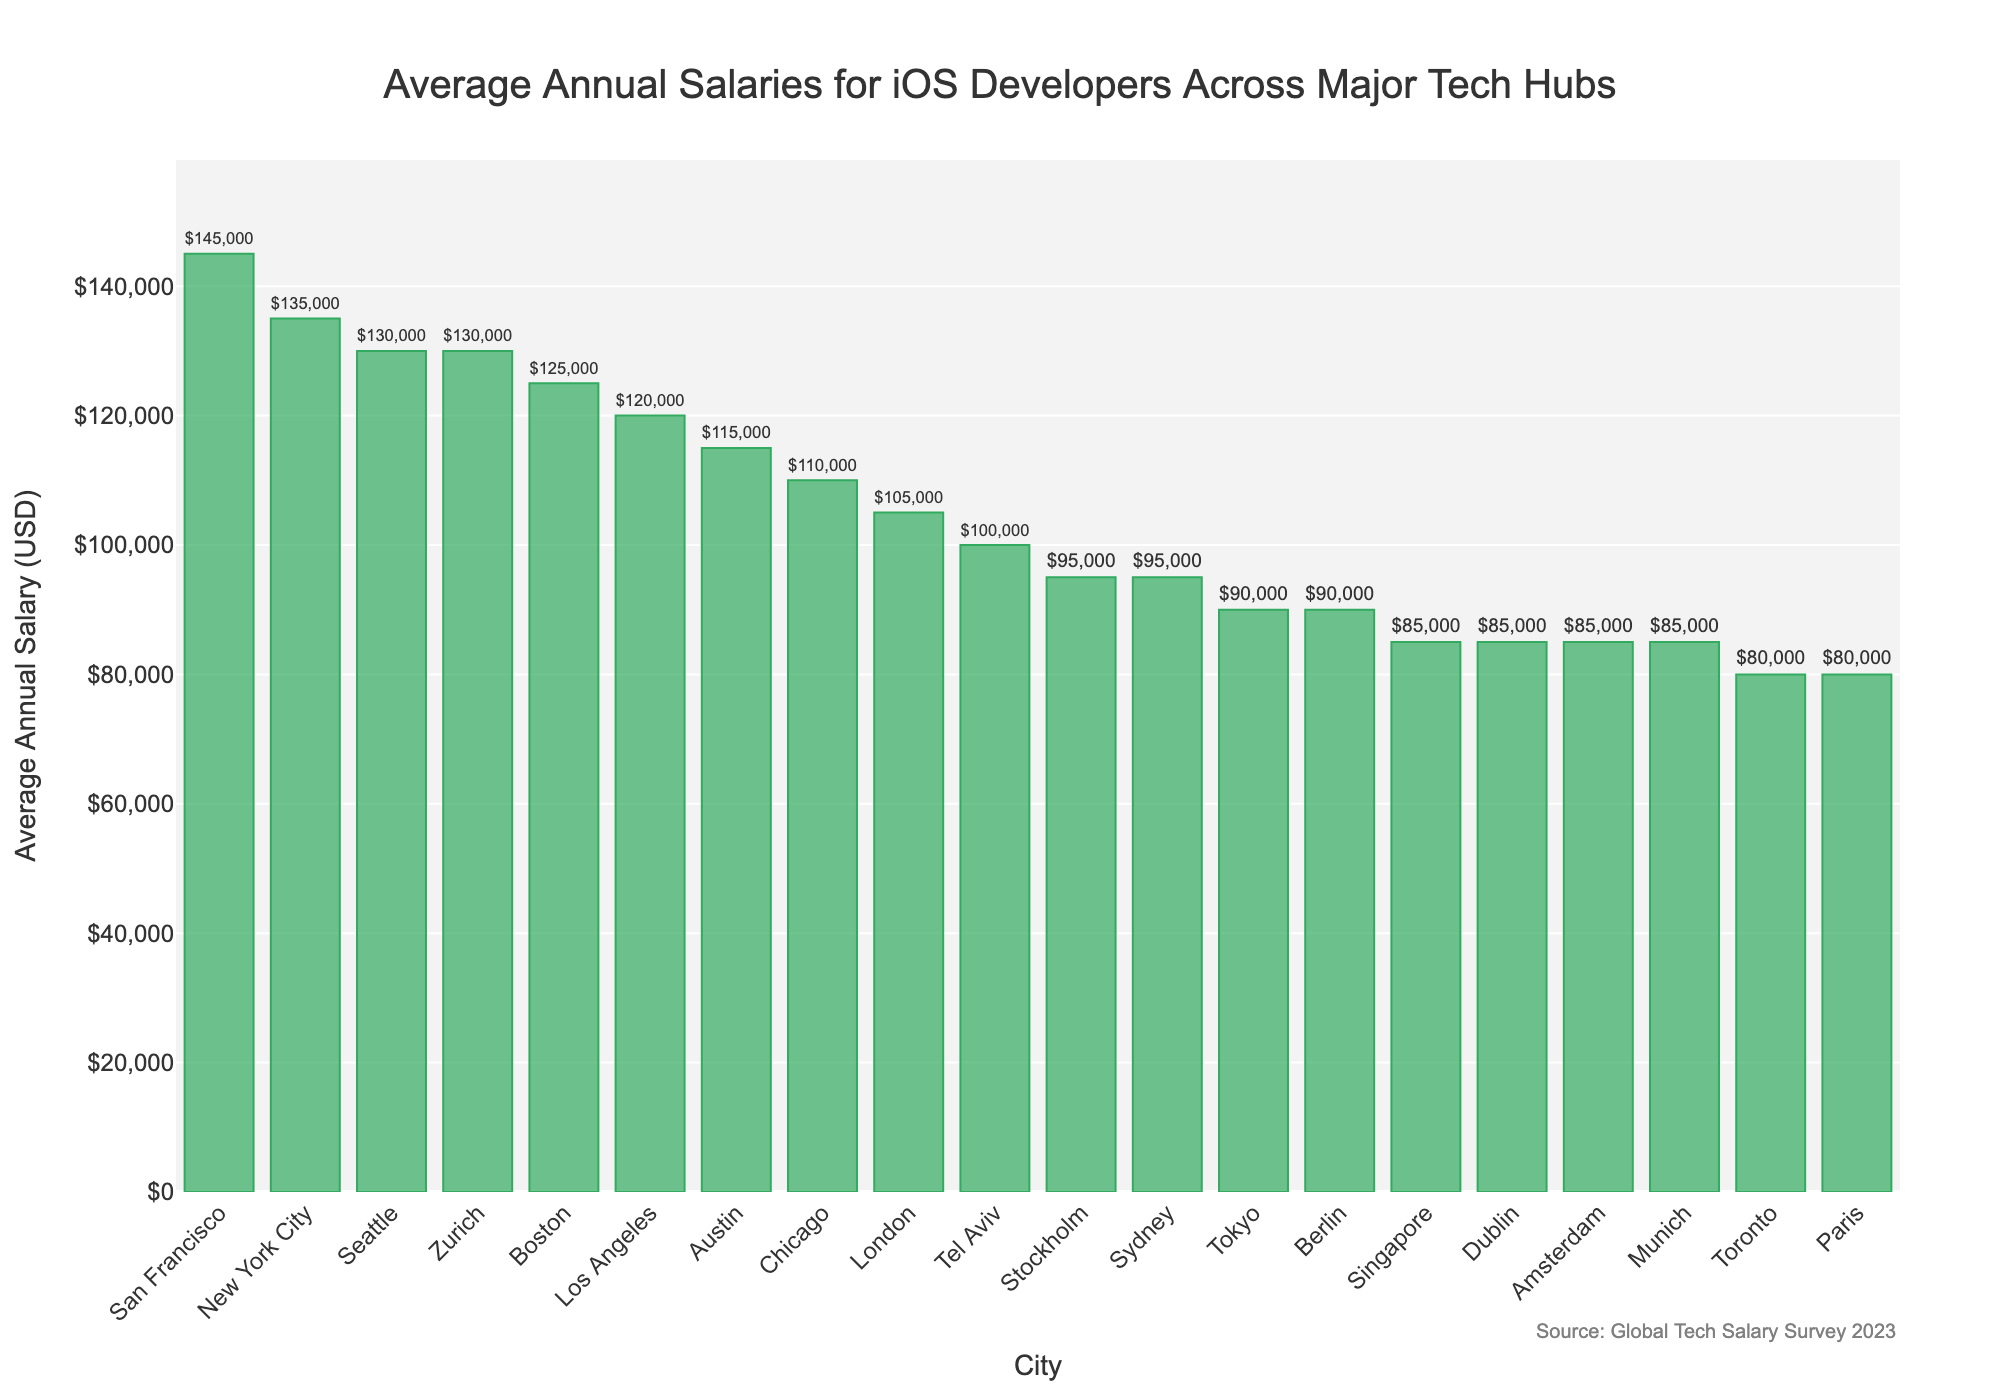How much higher is the average annual salary in San Francisco compared to Sydney? To find this, look at the average annual salaries of San Francisco ($145,000) and Sydney ($95,000). Then, subtract Sydney's salary from San Francisco's salary: $145,000 - $95,000 = $50,000
Answer: $50,000 Which city offers a higher average annual salary: Zurich or Seattle? According to the figure, Zurich and Seattle both offer an average annual salary of $130,000. Hence, they offer equal salaries.
Answer: Equal How many cities offer an average annual salary above $100,000? To find this, count all the cities where the bar's height indicates a salary above $100,000. These cities are San Francisco, New York City, Zurich, Seattle, Boston, Austin, Chicago, and Los Angeles. There are 8 such cities.
Answer: 8 Which city has the lowest average annual salary for iOS developers? By observing the bar chart, Paris and Toronto both have the lowest average annual salary of $80,000 for iOS developers.
Answer: Paris and Toronto What is the combined average annual salary of iOS developers in Tokyo and Berlin? Look at the average annual salaries of Tokyo ($90,000) and Berlin ($90,000). Add these two values together: $90,000 + $90,000 = $180,000
Answer: $180,000 Are there any cities with the same average annual salary, and if so, which ones? By reviewing the bars, Amsterdam, Singapore, Dublin, and Munich each have an average annual salary of $85,000, and Tokyo and Berlin each have an average annual salary of $90,000.
Answer: Amsterdam, Singapore, Dublin, Munich; Tokyo, Berlin What is the difference in salary between the highest paying city and the lowest paying city? The highest-paying city is San Francisco with $145,000, and the lowest-paying cities are Paris and Toronto with $80,000. The difference is $145,000 - $80,000 = $65,000
Answer: $65,000 How does the average salary in Berlin compare with the salary in Tel Aviv? The chart shows that both Berlin and Tel Aviv have average salaries very close, with Berlin at $90,000 and Tel Aviv at $100,000. The salary in Tel Aviv is slightly higher by $10,000.
Answer: $10,000 higher What's the average annual salary of iOS developers in the top three cities combined? The top three cities by salary are San Francisco ($145,000), New York City ($135,000), and Zurich ($130,000). Add these values together: $145,000 + $135,000 + $130,000 = $410,000
Answer: $410,000 Which cities have a salary difference of $30,000 or more when compared with San Francisco? San Francisco's salary is $145,000. Cities with salaries at least $30,000 lower are New York City ($135,000), Berlin ($90,000), Amsterdam ($85,000), Toronto ($80,000), Sydney ($95,000), Tokyo ($90,000), Singapore ($85,000), Stockholm ($95,000), and Paris ($80,000), etc. The difference varies, but all these and more fall into $30,000 difference category.
Answer: New York City, Berlin, Amsterdam, Toronto, Sydney, Tokyo, Singapore, Stockholm, Paris, etc 